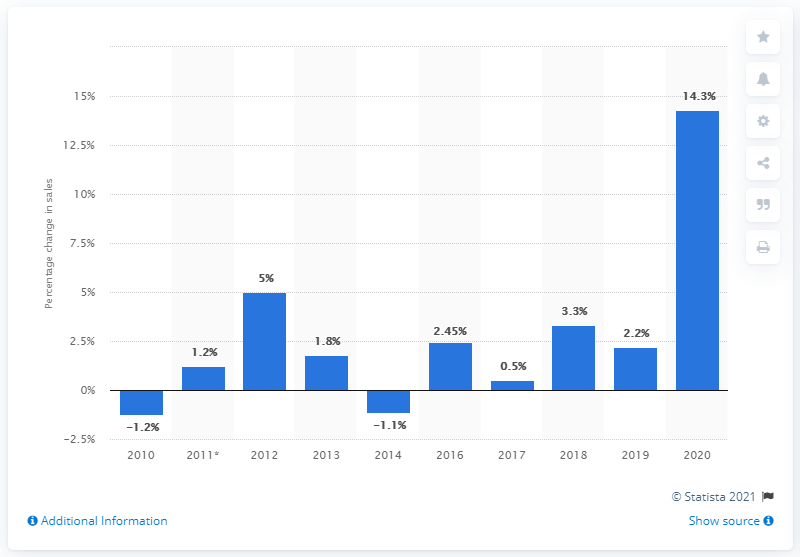Highlight a few significant elements in this photo. The sales value of over-the-counter (OTC) vitamins and minerals declined in the year 2010. 